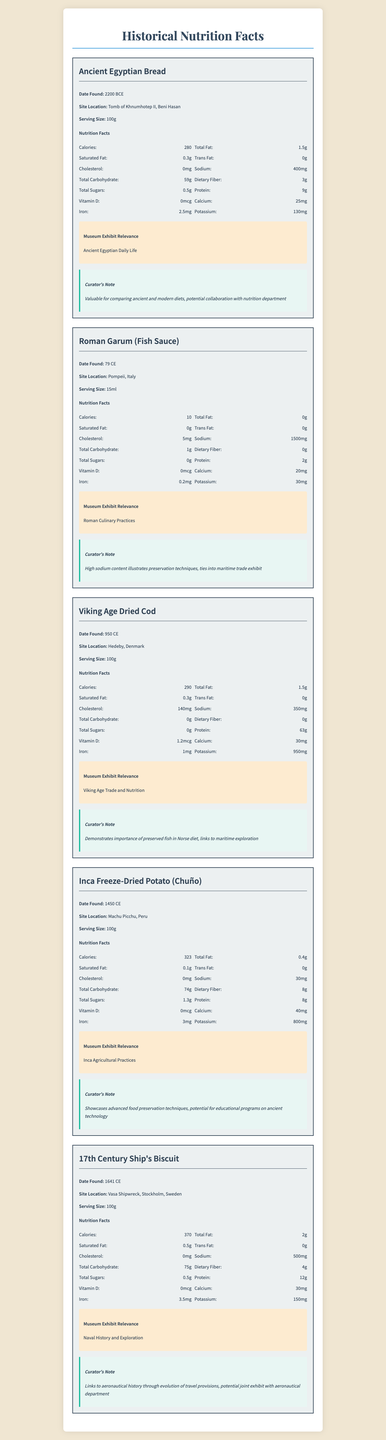What is the serving size for Ancient Egyptian Bread? The serving size for Ancient Egyptian Bread is specified as 100g in the nutrition facts section.
Answer: 100g Which food item has the highest sodium content per serving? A. Ancient Egyptian Bread B. Roman Garum C. Viking Age Dried Cod D. Inca Freeze-Dried Potato E. 17th Century Ship's Biscuit Roman Garum has the highest sodium content per serving at 1500mg, as stated in its nutrition facts.
Answer: B. Roman Garum True or False: The Inca Freeze-Dried Potato has more total carbohydrates than the 17th Century Ship's Biscuit. The Inca Freeze-Dried Potato has 74g of total carbohydrates, while the 17th Century Ship's Biscuit has 75g.
Answer: False Which food item has the highest protein content? The Viking Age Dried Cod has the highest protein content at 63g per serving.
Answer: Viking Age Dried Cod What is the museum exhibit relevance of the Roman Garum? The Roman Garum is relevant to the exhibit on Roman Culinary Practices, as noted in the exhibit relevance section.
Answer: Roman Culinary Practices How many calories does the 17th Century Ship's Biscuit contain? The 17th Century Ship's Biscuit contains 370 calories per serving.
Answer: 370 What is the purpose of the curator's note on the Ancient Egyptian Bread? A. Determine freshness B. Highlight nutritional value C. Suggest potential collaborations D. Indicate historical significance The curator's note mentions the potential for collaboration with the nutrition department to compare ancient and modern diets.
Answer: C. Suggest potential collaborations Which food item is not relevant to maritime exploration? A. Roman Garum B. Viking Age Dried Cod C. Inca Freeze-Dried Potato D. 17th Century Ship's Biscuit The Inca Freeze-Dried Potato is related to Inca Agricultural Practices, not maritime exploration.
Answer: C. Inca Freeze-Dried Potato Did the Ancient Egyptian Bread contain any Vitamin D? The nutrition facts for Ancient Egyptian Bread list Vitamin D as 0mcg, indicating it does not contain any Vitamin D.
Answer: No Provide a summary of the main idea of the document. The summary explains the overall structure and content of the document, describing how it presents nutritional data alongside historical context and curator insights for various preserved foods.
Answer: The document provides detailed nutritional information and historical context for a variety of preserved foods found in archaeological sites. Each item includes data on calories, fats, cholesterol, sodium, carbohydrates, sugars, protein, vitamins, and minerals. Additionally, the document highlights the museum exhibit relevance and includes curator notes on potential educational and collaborative opportunities. Is there any information on the preservation methods used for the preserved foods? The document provides the nutritional facts and historical context but does not detail the specific preservation methods used for the preserved foods.
Answer: Not enough information 